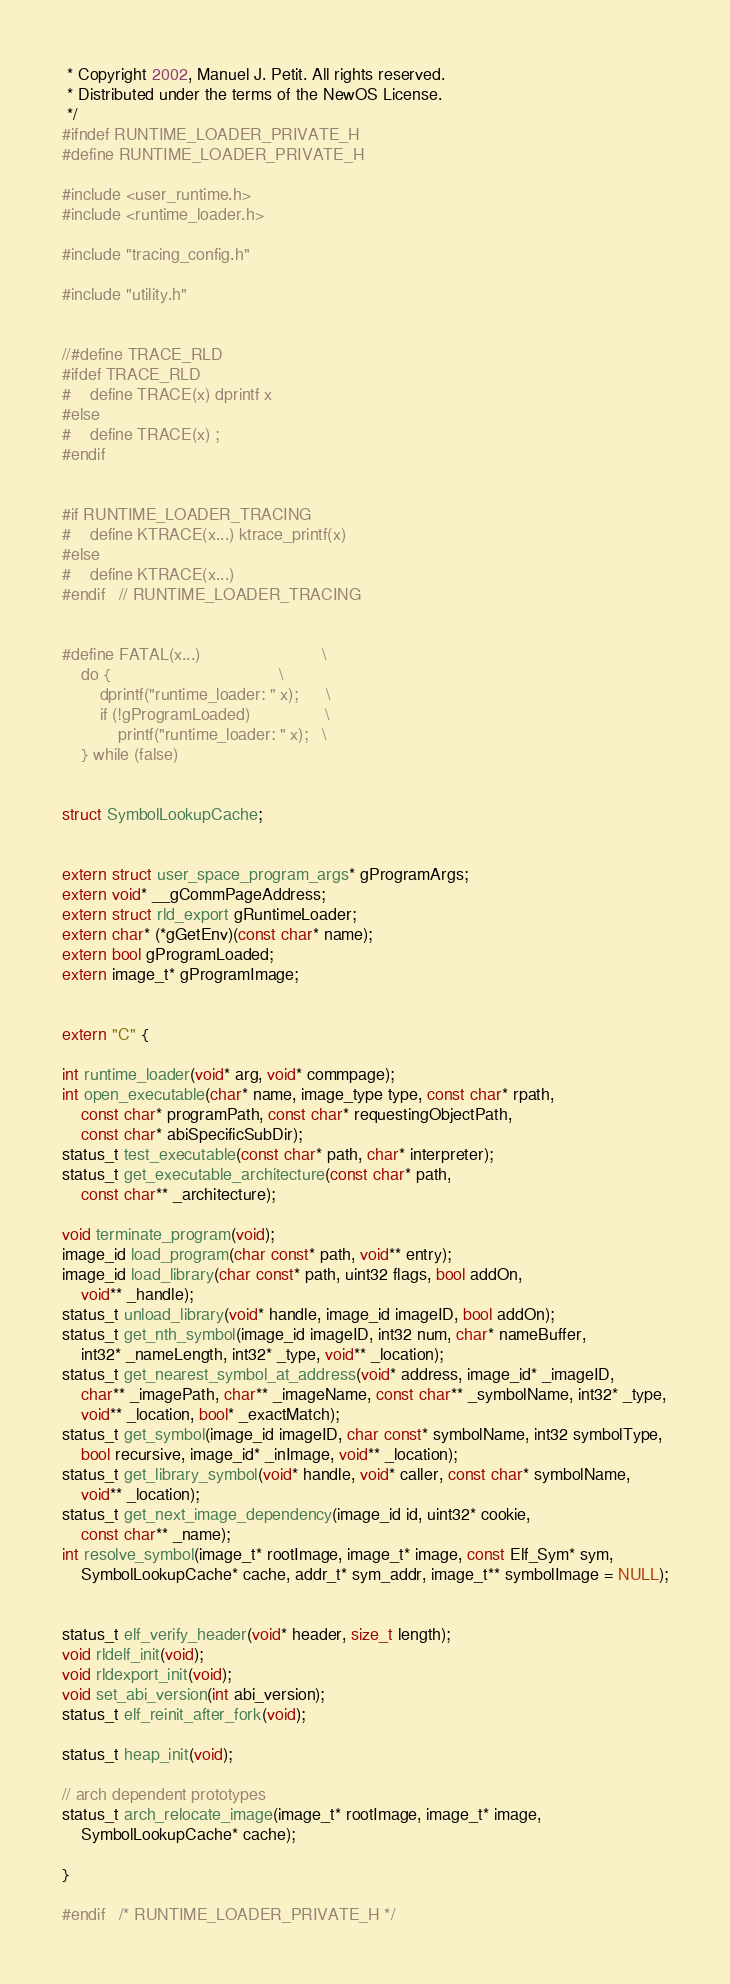Convert code to text. <code><loc_0><loc_0><loc_500><loc_500><_C_> * Copyright 2002, Manuel J. Petit. All rights reserved.
 * Distributed under the terms of the NewOS License.
 */
#ifndef RUNTIME_LOADER_PRIVATE_H
#define RUNTIME_LOADER_PRIVATE_H

#include <user_runtime.h>
#include <runtime_loader.h>

#include "tracing_config.h"

#include "utility.h"


//#define TRACE_RLD
#ifdef TRACE_RLD
#	define TRACE(x) dprintf x
#else
#	define TRACE(x) ;
#endif


#if RUNTIME_LOADER_TRACING
#	define KTRACE(x...)	ktrace_printf(x)
#else
#	define KTRACE(x...)
#endif	// RUNTIME_LOADER_TRACING


#define FATAL(x...)							\
	do {									\
		dprintf("runtime_loader: " x);		\
		if (!gProgramLoaded)				\
			printf("runtime_loader: " x);	\
	} while (false)


struct SymbolLookupCache;


extern struct user_space_program_args* gProgramArgs;
extern void* __gCommPageAddress;
extern struct rld_export gRuntimeLoader;
extern char* (*gGetEnv)(const char* name);
extern bool gProgramLoaded;
extern image_t* gProgramImage;


extern "C" {

int runtime_loader(void* arg, void* commpage);
int open_executable(char* name, image_type type, const char* rpath,
	const char* programPath, const char* requestingObjectPath,
	const char* abiSpecificSubDir);
status_t test_executable(const char* path, char* interpreter);
status_t get_executable_architecture(const char* path,
	const char** _architecture);

void terminate_program(void);
image_id load_program(char const* path, void** entry);
image_id load_library(char const* path, uint32 flags, bool addOn,
	void** _handle);
status_t unload_library(void* handle, image_id imageID, bool addOn);
status_t get_nth_symbol(image_id imageID, int32 num, char* nameBuffer,
	int32* _nameLength, int32* _type, void** _location);
status_t get_nearest_symbol_at_address(void* address, image_id* _imageID,
	char** _imagePath, char** _imageName, const char** _symbolName, int32* _type,
	void** _location, bool* _exactMatch);
status_t get_symbol(image_id imageID, char const* symbolName, int32 symbolType,
	bool recursive, image_id* _inImage, void** _location);
status_t get_library_symbol(void* handle, void* caller, const char* symbolName,
	void** _location);
status_t get_next_image_dependency(image_id id, uint32* cookie,
	const char** _name);
int resolve_symbol(image_t* rootImage, image_t* image, const Elf_Sym* sym,
	SymbolLookupCache* cache, addr_t* sym_addr, image_t** symbolImage = NULL);


status_t elf_verify_header(void* header, size_t length);
void rldelf_init(void);
void rldexport_init(void);
void set_abi_version(int abi_version);
status_t elf_reinit_after_fork(void);

status_t heap_init(void);

// arch dependent prototypes
status_t arch_relocate_image(image_t* rootImage, image_t* image,
	SymbolLookupCache* cache);

}

#endif	/* RUNTIME_LOADER_PRIVATE_H */
</code> 